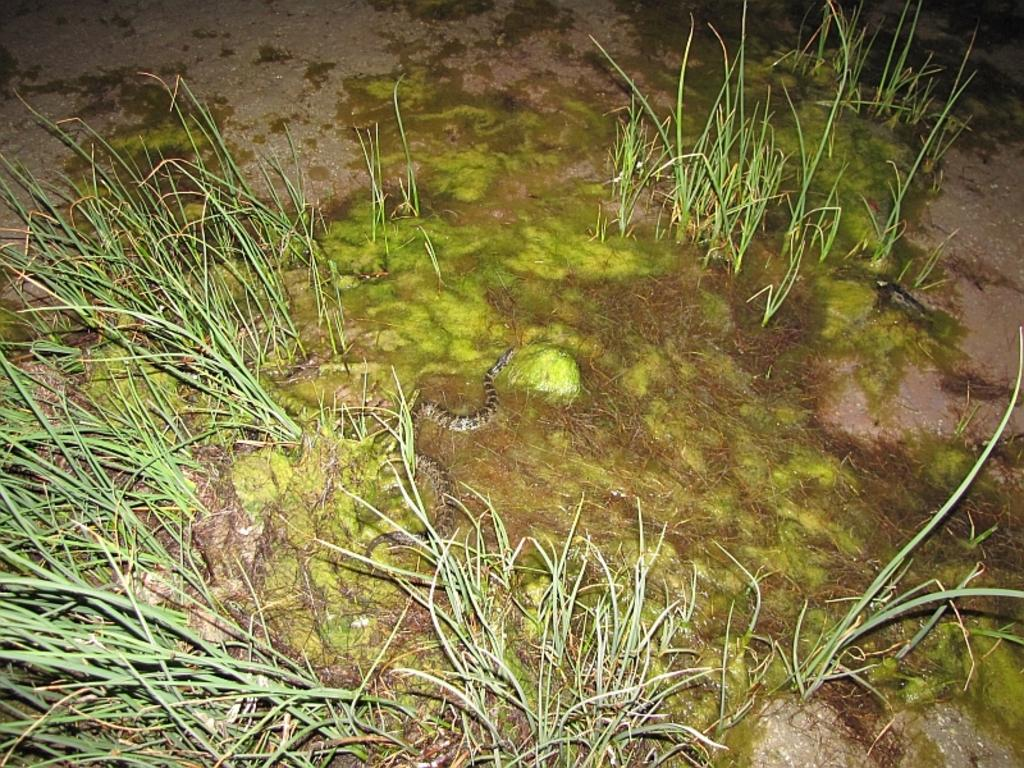What type of animal is in the image? There is a snake in the image. Where is the snake located? The snake is in the grass. How many pizzas are being served in the image? There are no pizzas present in the image; it features a snake in the grass. What historical event is depicted in the image? There is no historical event depicted in the image; it features a snake in the grass. 